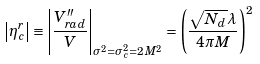<formula> <loc_0><loc_0><loc_500><loc_500>\left | \eta _ { c } ^ { r } \right | \equiv \left | \frac { V _ { r a d } ^ { \prime \prime } } { V } \right | _ { \sigma ^ { 2 } = \sigma _ { c } ^ { 2 } = 2 M ^ { 2 } } = \left ( \frac { \sqrt { N _ { d } } \lambda } { 4 \pi M } \right ) ^ { 2 }</formula> 